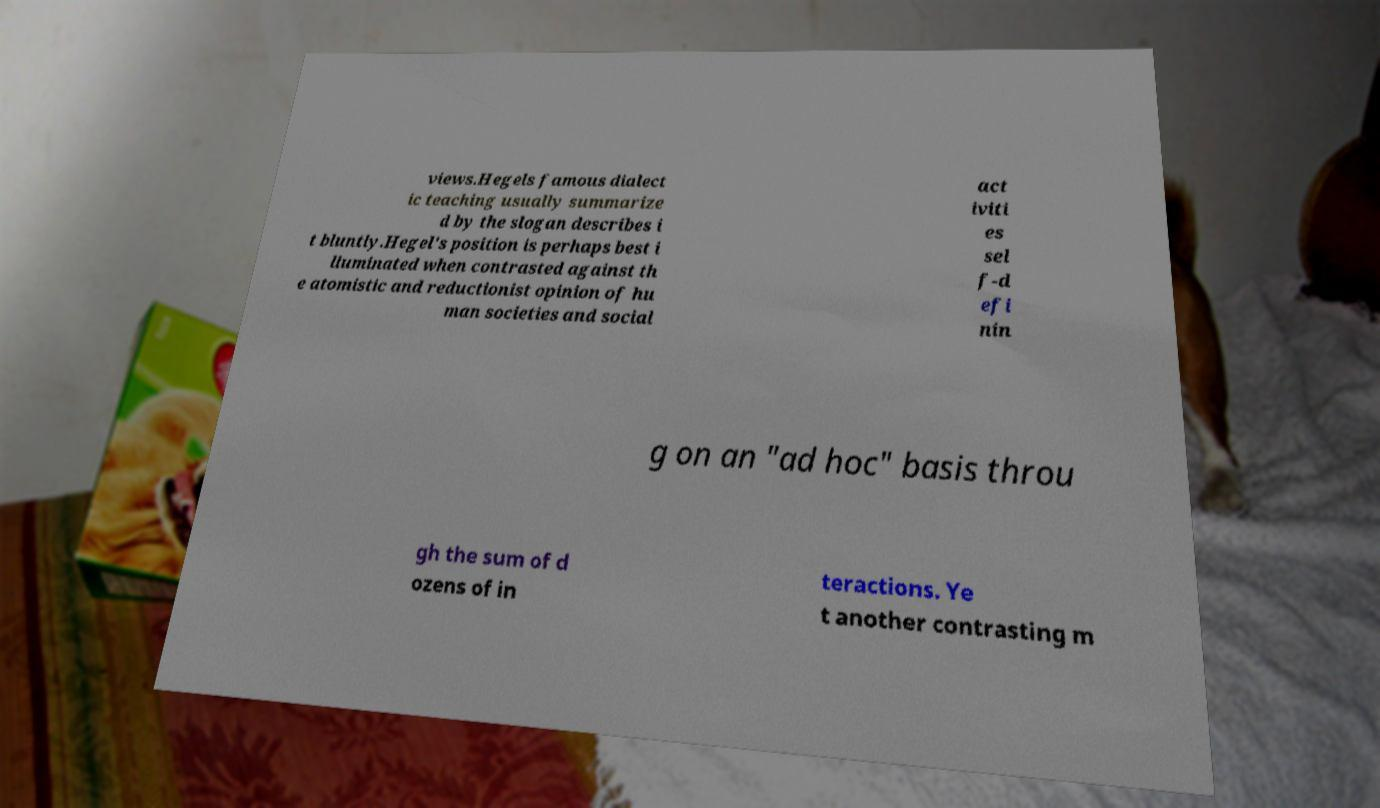Could you extract and type out the text from this image? views.Hegels famous dialect ic teaching usually summarize d by the slogan describes i t bluntly.Hegel's position is perhaps best i lluminated when contrasted against th e atomistic and reductionist opinion of hu man societies and social act iviti es sel f-d efi nin g on an "ad hoc" basis throu gh the sum of d ozens of in teractions. Ye t another contrasting m 